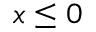Convert formula to latex. <formula><loc_0><loc_0><loc_500><loc_500>x \leq 0</formula> 